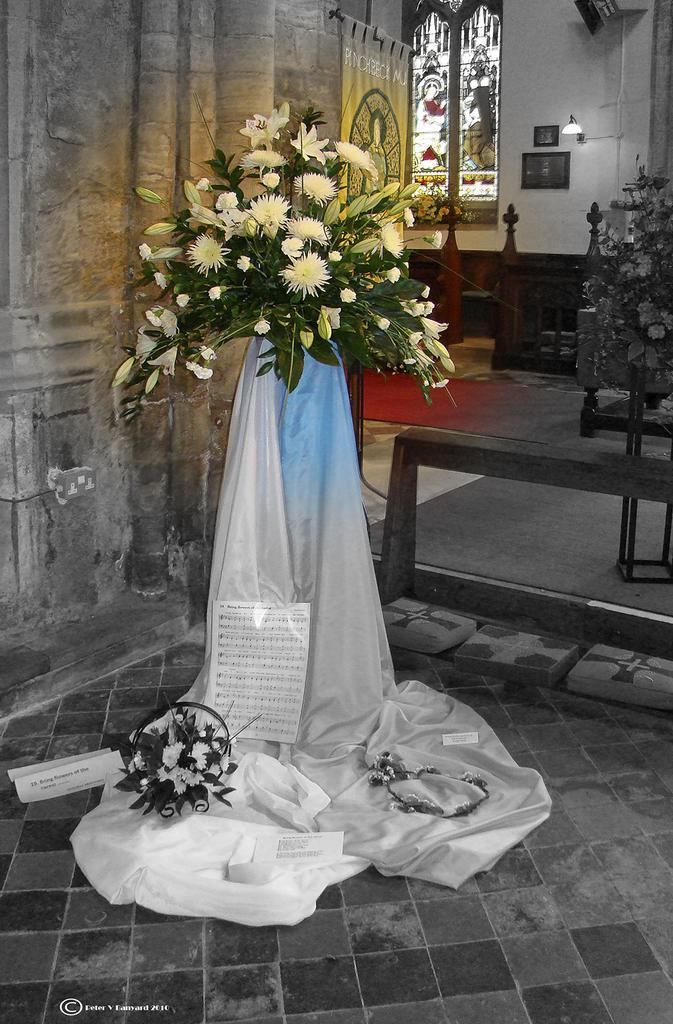Describe this image in one or two sentences. In this picture we can see the inside view of a building. Inside the building, there is a cloth on an object. On the cloth, there are papers, a decorative plant and other things. Behind the decorative plant, there is a banner and a stained glass window. On the right side of the stained glass window, there is a lamp and some objects are attached to a wall. On the right side of the image, there are some objects. 